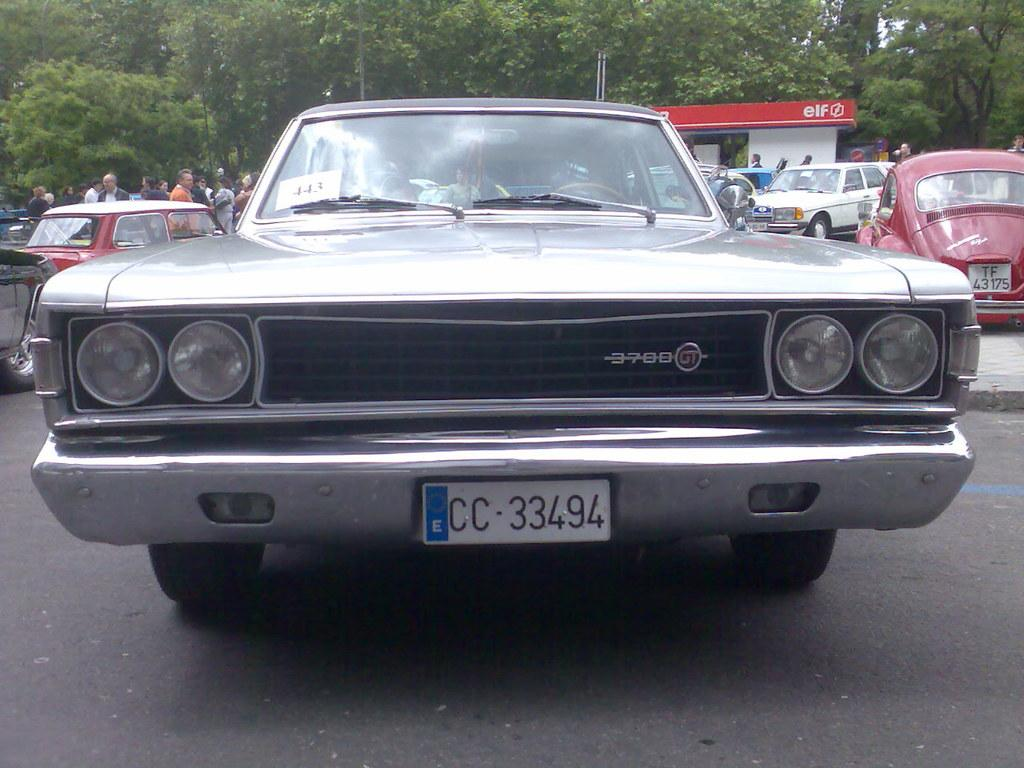What is located in the foreground of the picture? There are cars and a room in the foreground of the picture. What can be seen in the background of the picture? There are people and trees in the background of the picture. What type of earthquake can be seen in the image? There is no earthquake present in the image. What kind of vessel is being used by the people in the background? There is no vessel visible in the image; the people are not shown using any specific object. 